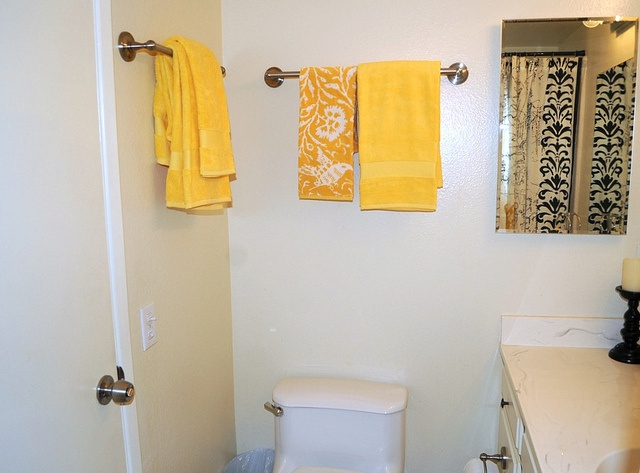Describe the objects in this image and their specific colors. I can see toilet in lightgray and darkgray tones and sink in lightgray, darkgray, gray, tan, and olive tones in this image. 